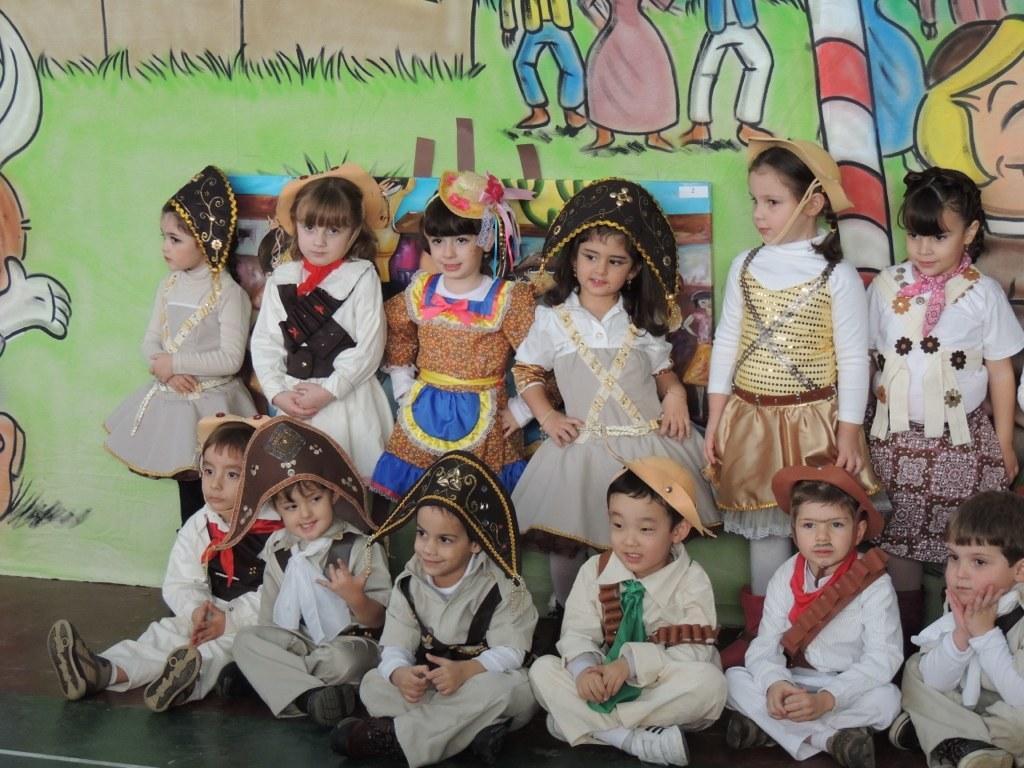Describe this image in one or two sentences. In this image I can see few children wearing costumes and giving pose for the picture. In the front few children are sitting on the floor, at the back few children are standing and leaning to the wall. On the wall, I can see some paintings. 